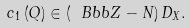Convert formula to latex. <formula><loc_0><loc_0><loc_500><loc_500>c _ { 1 } \left ( Q \right ) \in \left ( \ B b b { Z - N } \right ) D _ { X } .</formula> 